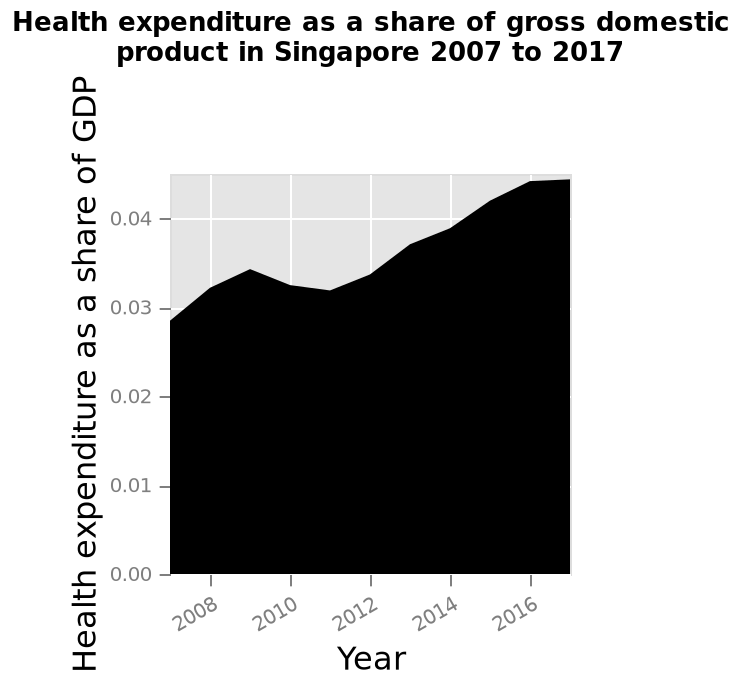<image>
What is the range of the x-axis in the area chart?  The range of the x-axis in the area chart is from 2008 to 2016. What was the initial level of health expenditure as a share of GDP?  The initial level of health expenditure as a share of GDP was just below 0.03. Was the initial level of health expenditure as a share of GDP just above 0.03? No. The initial level of health expenditure as a share of GDP was just below 0.03. 